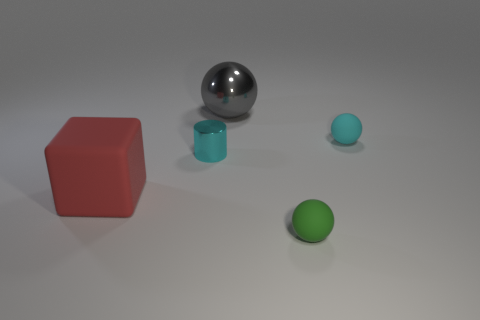Subtract all brown spheres. Subtract all purple cylinders. How many spheres are left? 3 Subtract all purple balls. How many purple blocks are left? 0 Add 5 tiny cyans. How many tiny greens exist? 0 Subtract all tiny things. Subtract all brown cylinders. How many objects are left? 2 Add 5 tiny rubber objects. How many tiny rubber objects are left? 7 Add 4 gray metal cylinders. How many gray metal cylinders exist? 4 Add 4 gray objects. How many objects exist? 9 Subtract all cyan spheres. How many spheres are left? 2 Subtract all large gray shiny spheres. How many spheres are left? 2 Subtract 0 cyan blocks. How many objects are left? 5 